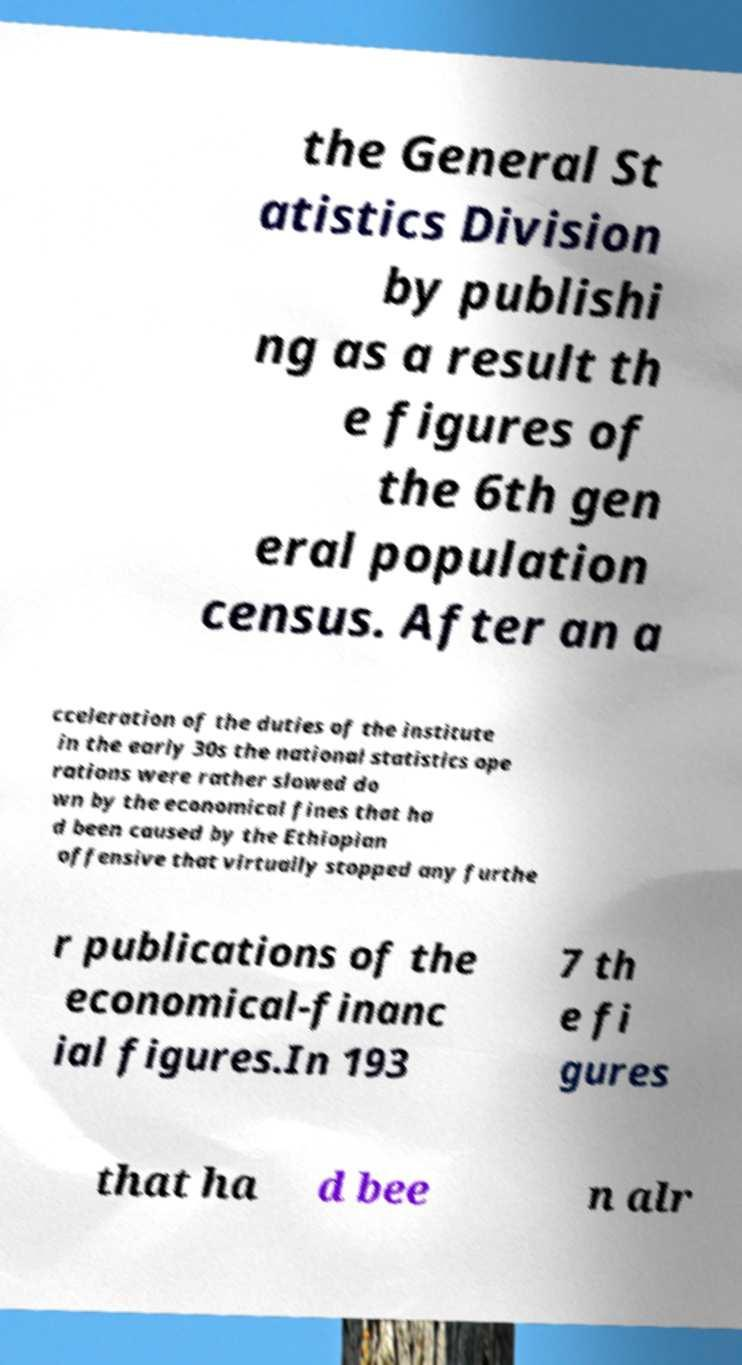Can you accurately transcribe the text from the provided image for me? the General St atistics Division by publishi ng as a result th e figures of the 6th gen eral population census. After an a cceleration of the duties of the institute in the early 30s the national statistics ope rations were rather slowed do wn by the economical fines that ha d been caused by the Ethiopian offensive that virtually stopped any furthe r publications of the economical-financ ial figures.In 193 7 th e fi gures that ha d bee n alr 